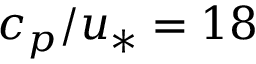<formula> <loc_0><loc_0><loc_500><loc_500>c _ { p } / u _ { * } = 1 8</formula> 